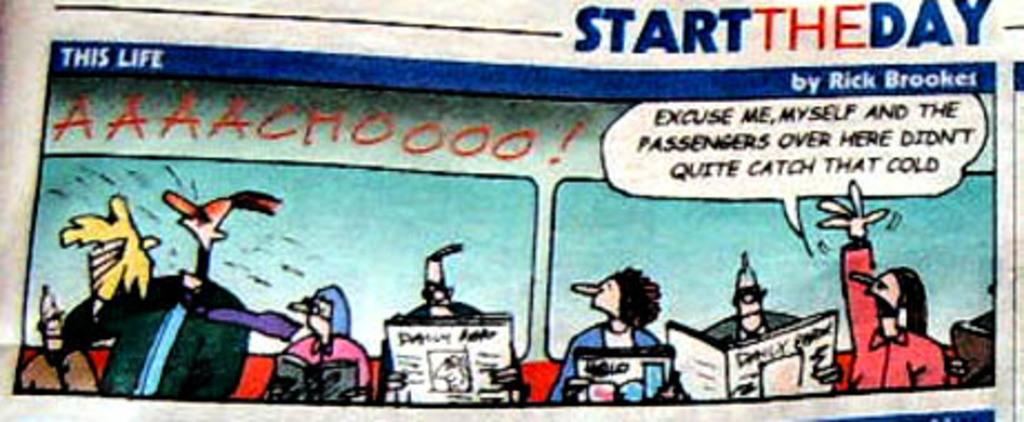What did the passengers in this comic avoid?
Your answer should be very brief. Cold. What is the title of the comic?
Make the answer very short. This life. 